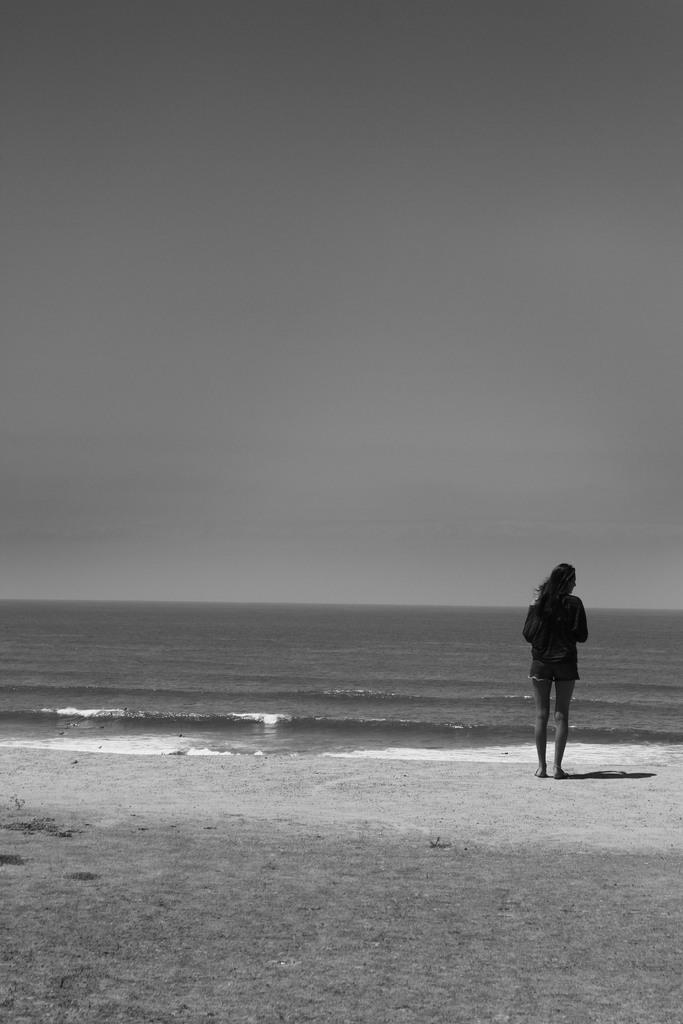What type of surface is visible in the image? The image has a sand surface. What is the woman in the image doing? The woman is standing on the sand surface. What is in front of the woman? Water is visible in front of the woman. What can be seen above the sand and water in the image? The sky is visible in the image. What type of credit card is the woman using to purchase the sand in the image? There is no credit card or purchase of sand depicted in the image. Can you tell me how many trucks are visible in the image? There are no trucks present in the image. 